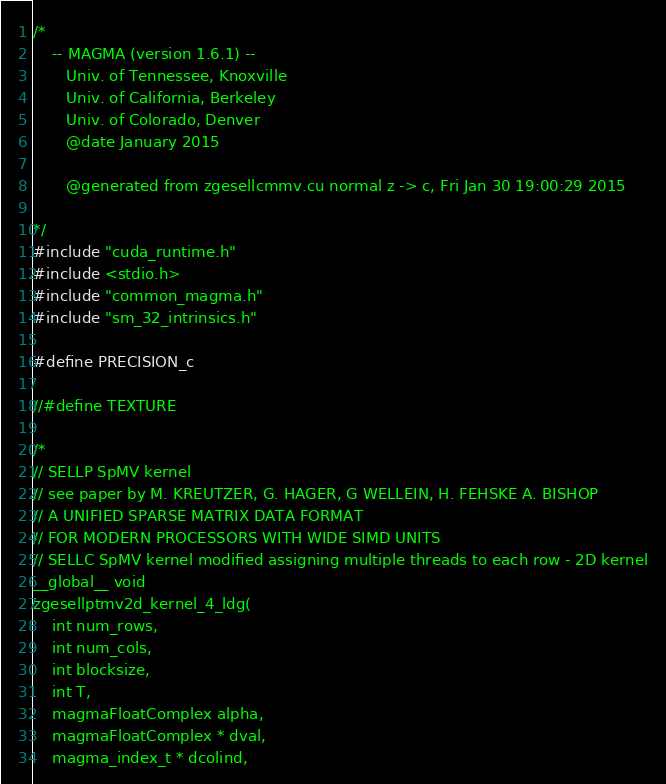Convert code to text. <code><loc_0><loc_0><loc_500><loc_500><_Cuda_>/*
    -- MAGMA (version 1.6.1) --
       Univ. of Tennessee, Knoxville
       Univ. of California, Berkeley
       Univ. of Colorado, Denver
       @date January 2015

       @generated from zgesellcmmv.cu normal z -> c, Fri Jan 30 19:00:29 2015

*/
#include "cuda_runtime.h"
#include <stdio.h>
#include "common_magma.h"
#include "sm_32_intrinsics.h"

#define PRECISION_c

//#define TEXTURE

/*
// SELLP SpMV kernel
// see paper by M. KREUTZER, G. HAGER, G WELLEIN, H. FEHSKE A. BISHOP
// A UNIFIED SPARSE MATRIX DATA FORMAT 
// FOR MODERN PROCESSORS WITH WIDE SIMD UNITS
// SELLC SpMV kernel modified assigning multiple threads to each row - 2D kernel
__global__ void 
zgesellptmv2d_kernel_4_ldg( 
    int num_rows, 
    int num_cols,
    int blocksize,
    int T,
    magmaFloatComplex alpha, 
    magmaFloatComplex * dval, 
    magma_index_t * dcolind,</code> 